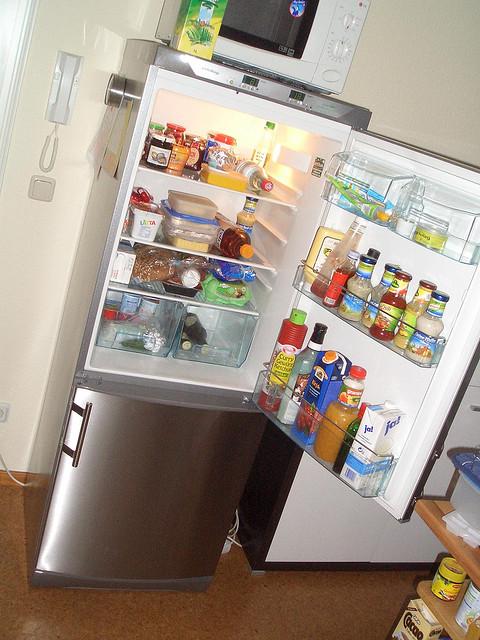What are you going to make for a snack?
Be succinct. Sandwich. Is the fridge open?
Concise answer only. Yes. Is this a home kitchen?
Give a very brief answer. Yes. 